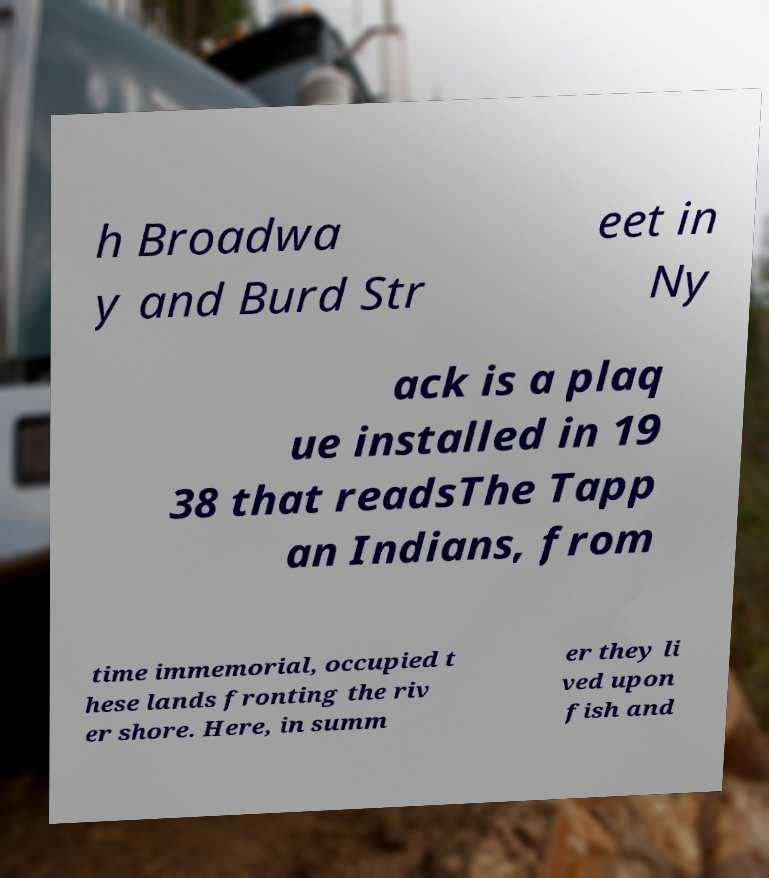Please identify and transcribe the text found in this image. h Broadwa y and Burd Str eet in Ny ack is a plaq ue installed in 19 38 that readsThe Tapp an Indians, from time immemorial, occupied t hese lands fronting the riv er shore. Here, in summ er they li ved upon fish and 